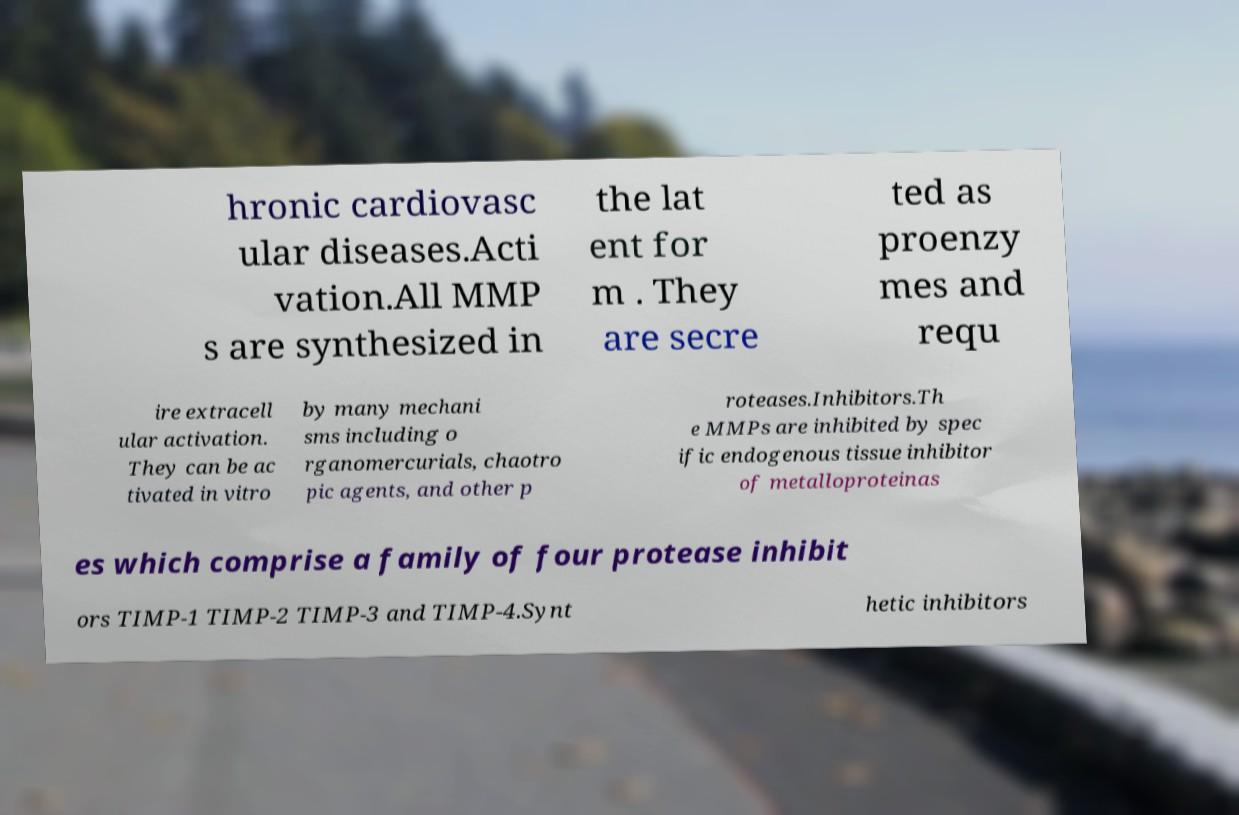Could you assist in decoding the text presented in this image and type it out clearly? hronic cardiovasc ular diseases.Acti vation.All MMP s are synthesized in the lat ent for m . They are secre ted as proenzy mes and requ ire extracell ular activation. They can be ac tivated in vitro by many mechani sms including o rganomercurials, chaotro pic agents, and other p roteases.Inhibitors.Th e MMPs are inhibited by spec ific endogenous tissue inhibitor of metalloproteinas es which comprise a family of four protease inhibit ors TIMP-1 TIMP-2 TIMP-3 and TIMP-4.Synt hetic inhibitors 